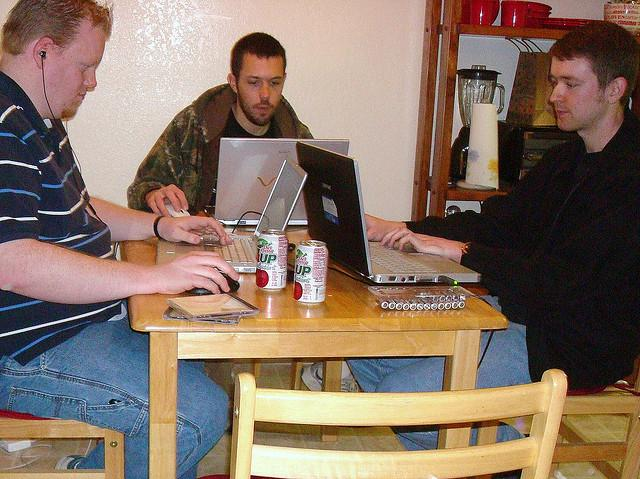Why are they all there together? Please explain your reasoning. sharing table. They may be c in a shared video game or about to do b together. 